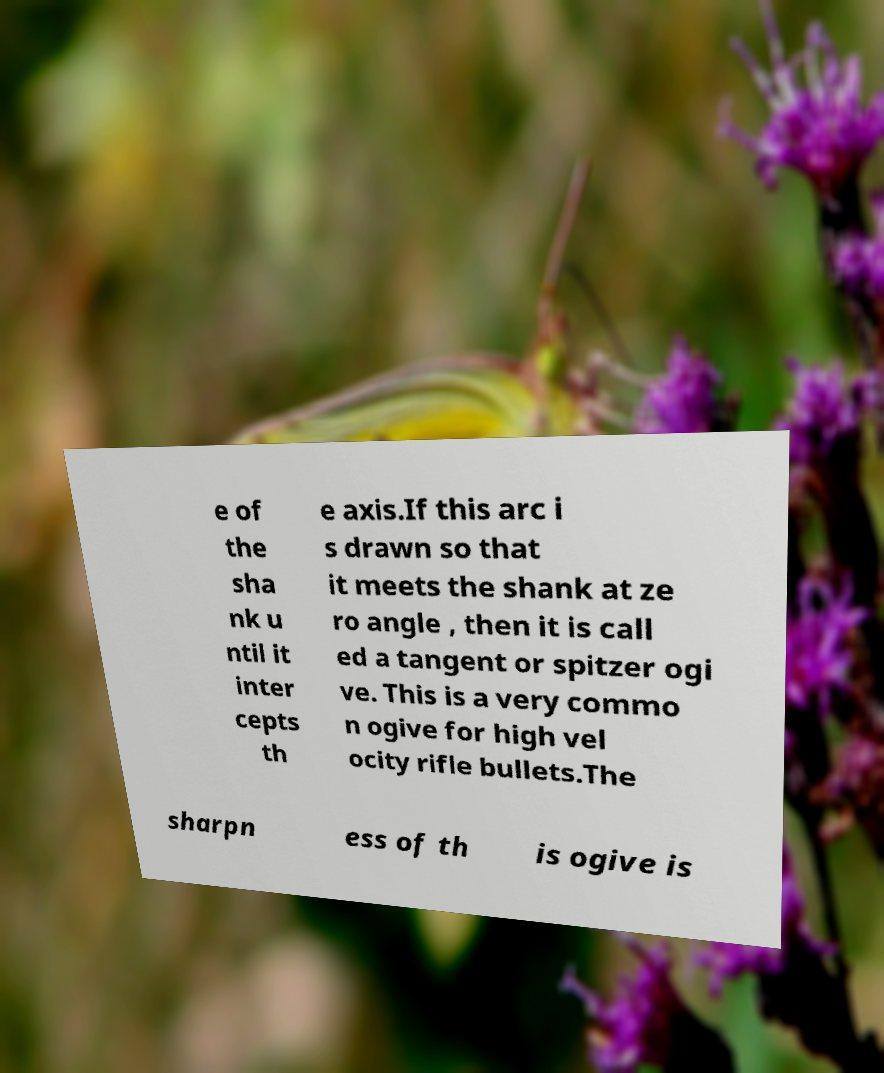Can you read and provide the text displayed in the image?This photo seems to have some interesting text. Can you extract and type it out for me? e of the sha nk u ntil it inter cepts th e axis.If this arc i s drawn so that it meets the shank at ze ro angle , then it is call ed a tangent or spitzer ogi ve. This is a very commo n ogive for high vel ocity rifle bullets.The sharpn ess of th is ogive is 